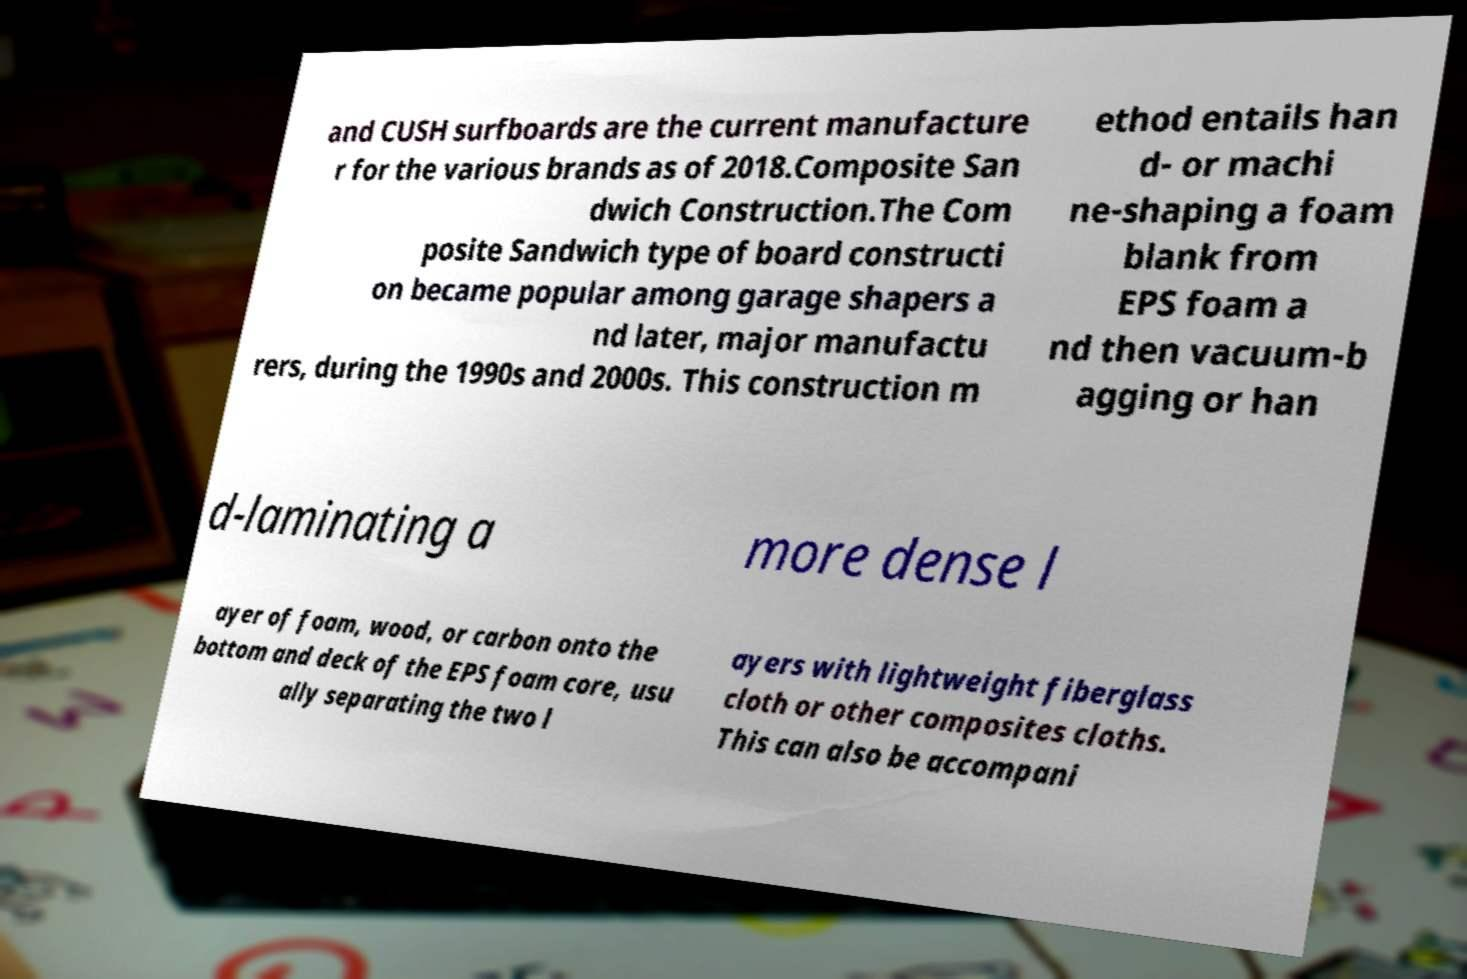What messages or text are displayed in this image? I need them in a readable, typed format. and CUSH surfboards are the current manufacture r for the various brands as of 2018.Composite San dwich Construction.The Com posite Sandwich type of board constructi on became popular among garage shapers a nd later, major manufactu rers, during the 1990s and 2000s. This construction m ethod entails han d- or machi ne-shaping a foam blank from EPS foam a nd then vacuum-b agging or han d-laminating a more dense l ayer of foam, wood, or carbon onto the bottom and deck of the EPS foam core, usu ally separating the two l ayers with lightweight fiberglass cloth or other composites cloths. This can also be accompani 